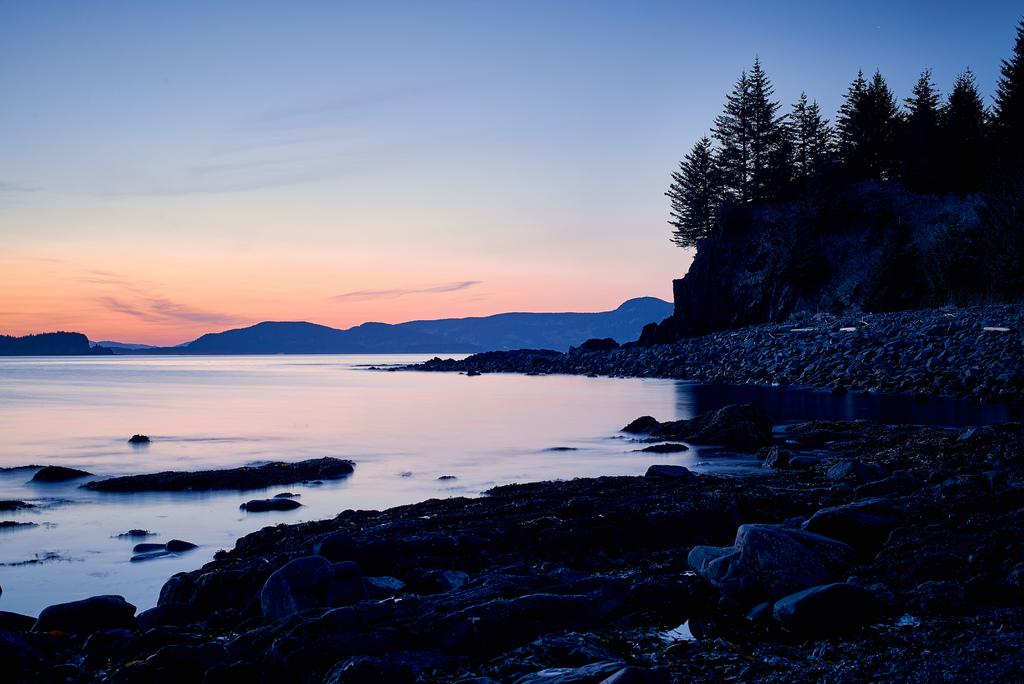What is the primary element in the image? There is water in the image. What geographical features are located near the water? There are mountains beside the water. What type of vegetation can be seen in the image? Trees are present in the image. What other natural elements are visible in the image? Rocks and stones are present in the image. What part of the natural environment is visible in the image? The sky is visible in the image. What opinions do the pets have about the sidewalk in the image? There are no pets or sidewalks present in the image. 